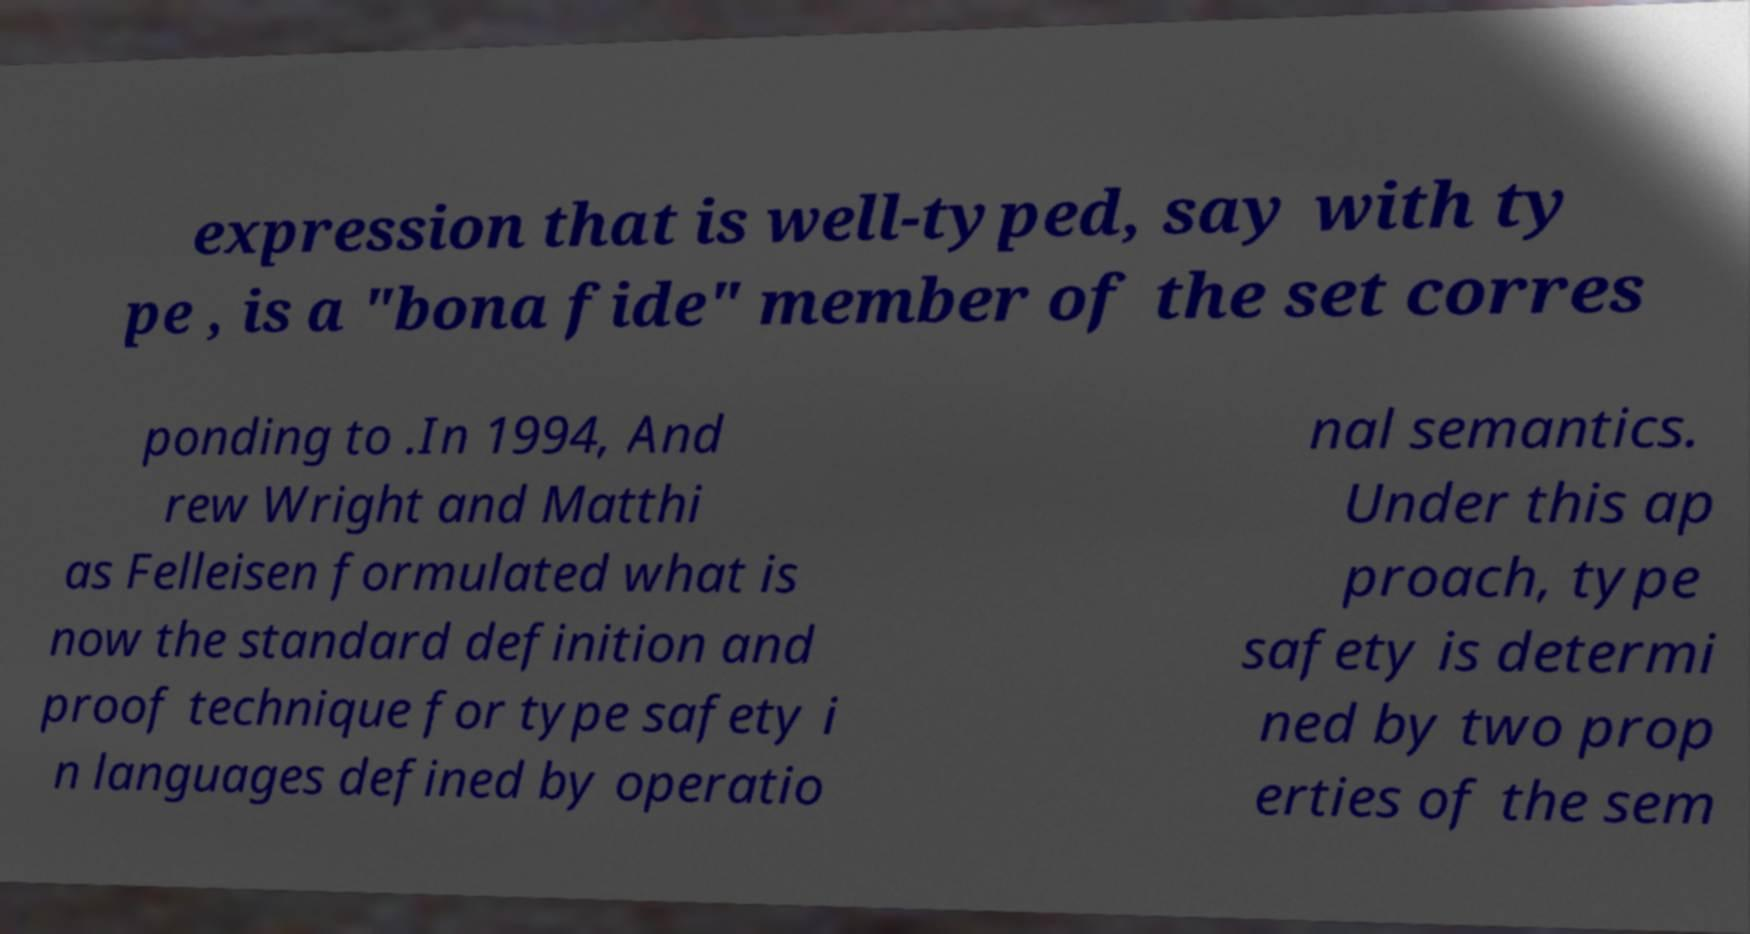Could you assist in decoding the text presented in this image and type it out clearly? expression that is well-typed, say with ty pe , is a "bona fide" member of the set corres ponding to .In 1994, And rew Wright and Matthi as Felleisen formulated what is now the standard definition and proof technique for type safety i n languages defined by operatio nal semantics. Under this ap proach, type safety is determi ned by two prop erties of the sem 